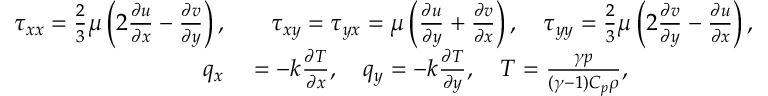Convert formula to latex. <formula><loc_0><loc_0><loc_500><loc_500>\begin{array} { r l } { \tau _ { x x } = \frac { 2 } { 3 } \mu \left ( 2 \frac { \partial u } { \partial x } - \frac { \partial v } { \partial y } \right ) , } & \quad \tau _ { x y } = \tau _ { y x } = \mu \left ( \frac { \partial u } { \partial y } + \frac { \partial v } { \partial x } \right ) , \quad \tau _ { y y } = \frac { 2 } { 3 } \mu \left ( 2 \frac { \partial v } { \partial y } - \frac { \partial u } { \partial x } \right ) , } \\ { q _ { x } } & = - k \frac { \partial T } { \partial x } , \quad q _ { y } = - k \frac { \partial T } { \partial y } , \quad T = \frac { \gamma p } { ( \gamma - 1 ) C _ { p } \rho } , } \end{array}</formula> 